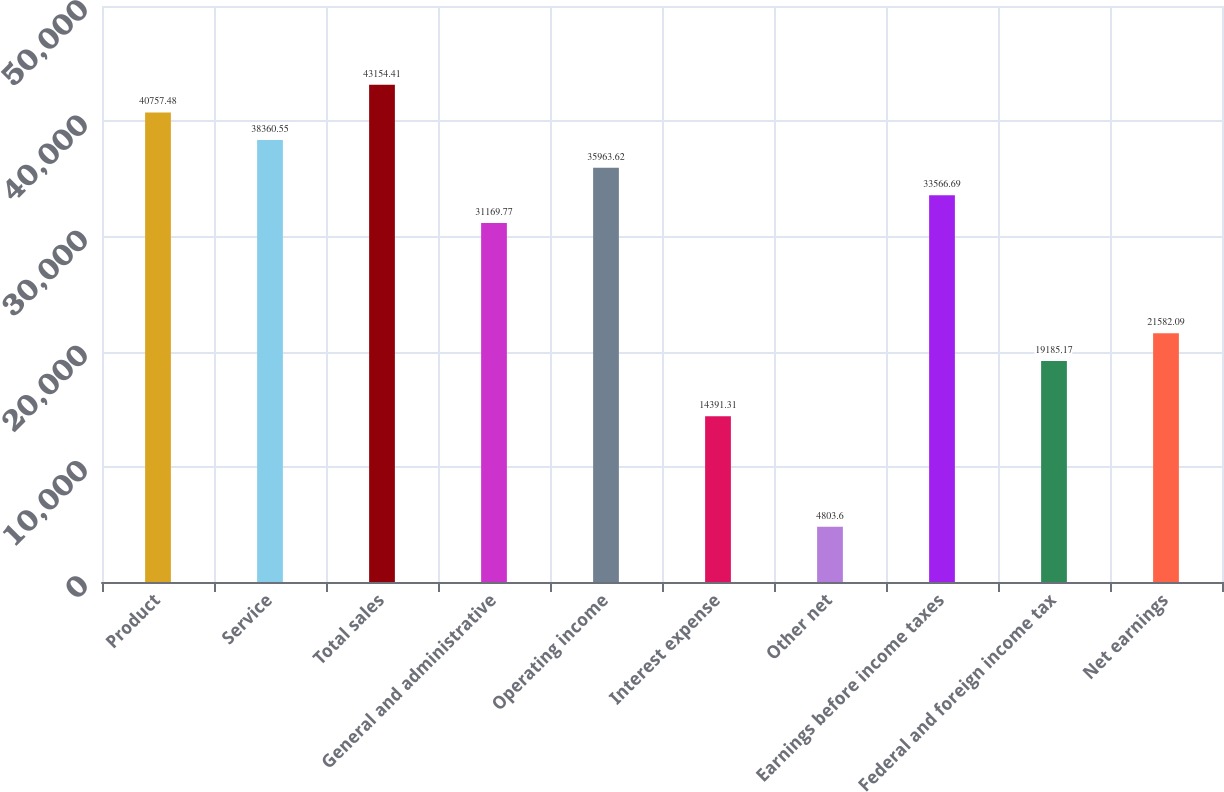Convert chart. <chart><loc_0><loc_0><loc_500><loc_500><bar_chart><fcel>Product<fcel>Service<fcel>Total sales<fcel>General and administrative<fcel>Operating income<fcel>Interest expense<fcel>Other net<fcel>Earnings before income taxes<fcel>Federal and foreign income tax<fcel>Net earnings<nl><fcel>40757.5<fcel>38360.6<fcel>43154.4<fcel>31169.8<fcel>35963.6<fcel>14391.3<fcel>4803.6<fcel>33566.7<fcel>19185.2<fcel>21582.1<nl></chart> 